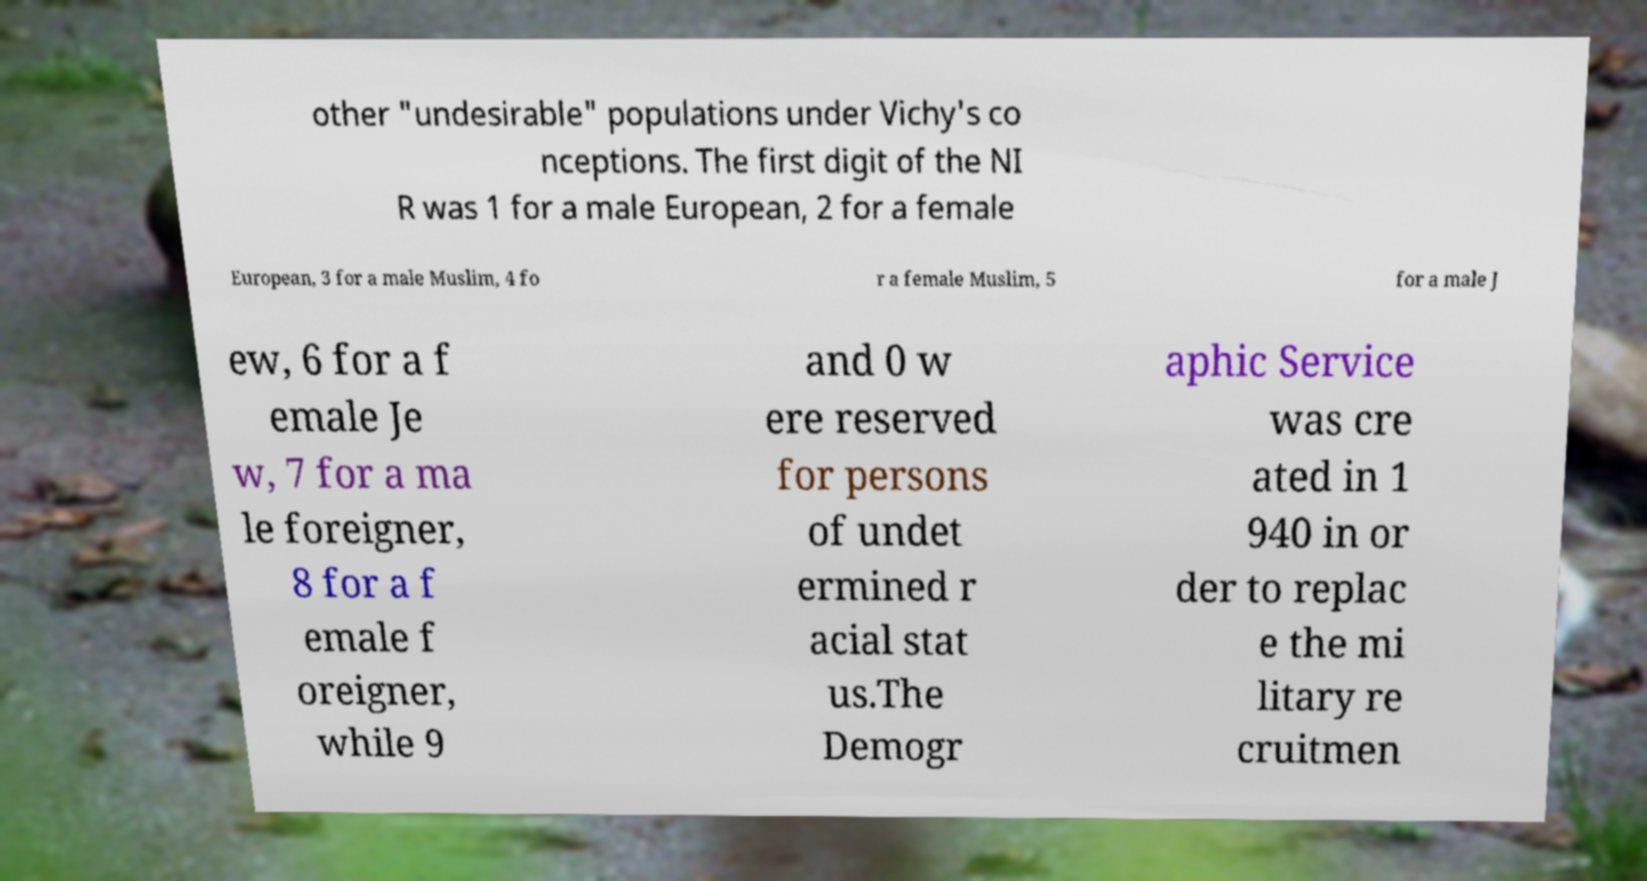Please identify and transcribe the text found in this image. other "undesirable" populations under Vichy's co nceptions. The first digit of the NI R was 1 for a male European, 2 for a female European, 3 for a male Muslim, 4 fo r a female Muslim, 5 for a male J ew, 6 for a f emale Je w, 7 for a ma le foreigner, 8 for a f emale f oreigner, while 9 and 0 w ere reserved for persons of undet ermined r acial stat us.The Demogr aphic Service was cre ated in 1 940 in or der to replac e the mi litary re cruitmen 